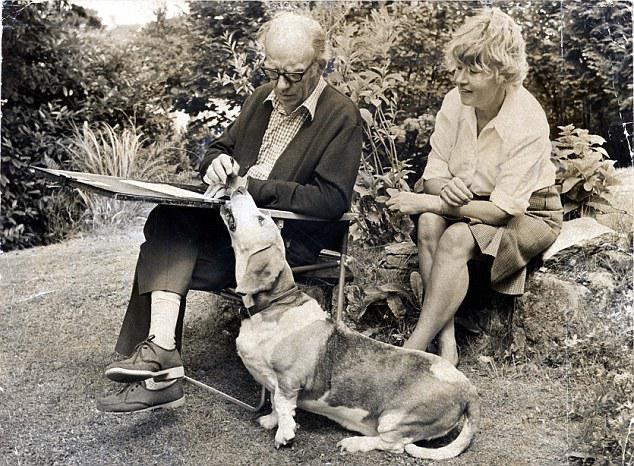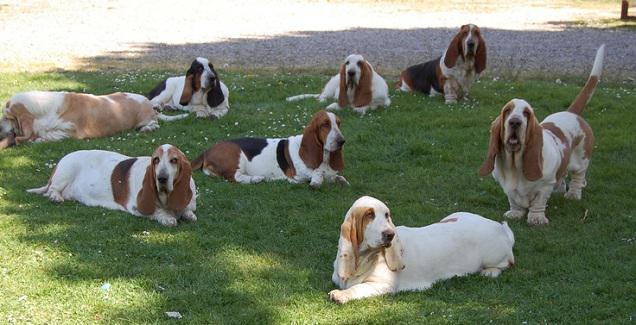The first image is the image on the left, the second image is the image on the right. Given the left and right images, does the statement "There are no more than eight dogs in the right image." hold true? Answer yes or no. Yes. The first image is the image on the left, the second image is the image on the right. Given the left and right images, does the statement "Every single image contains more than one dog." hold true? Answer yes or no. No. 